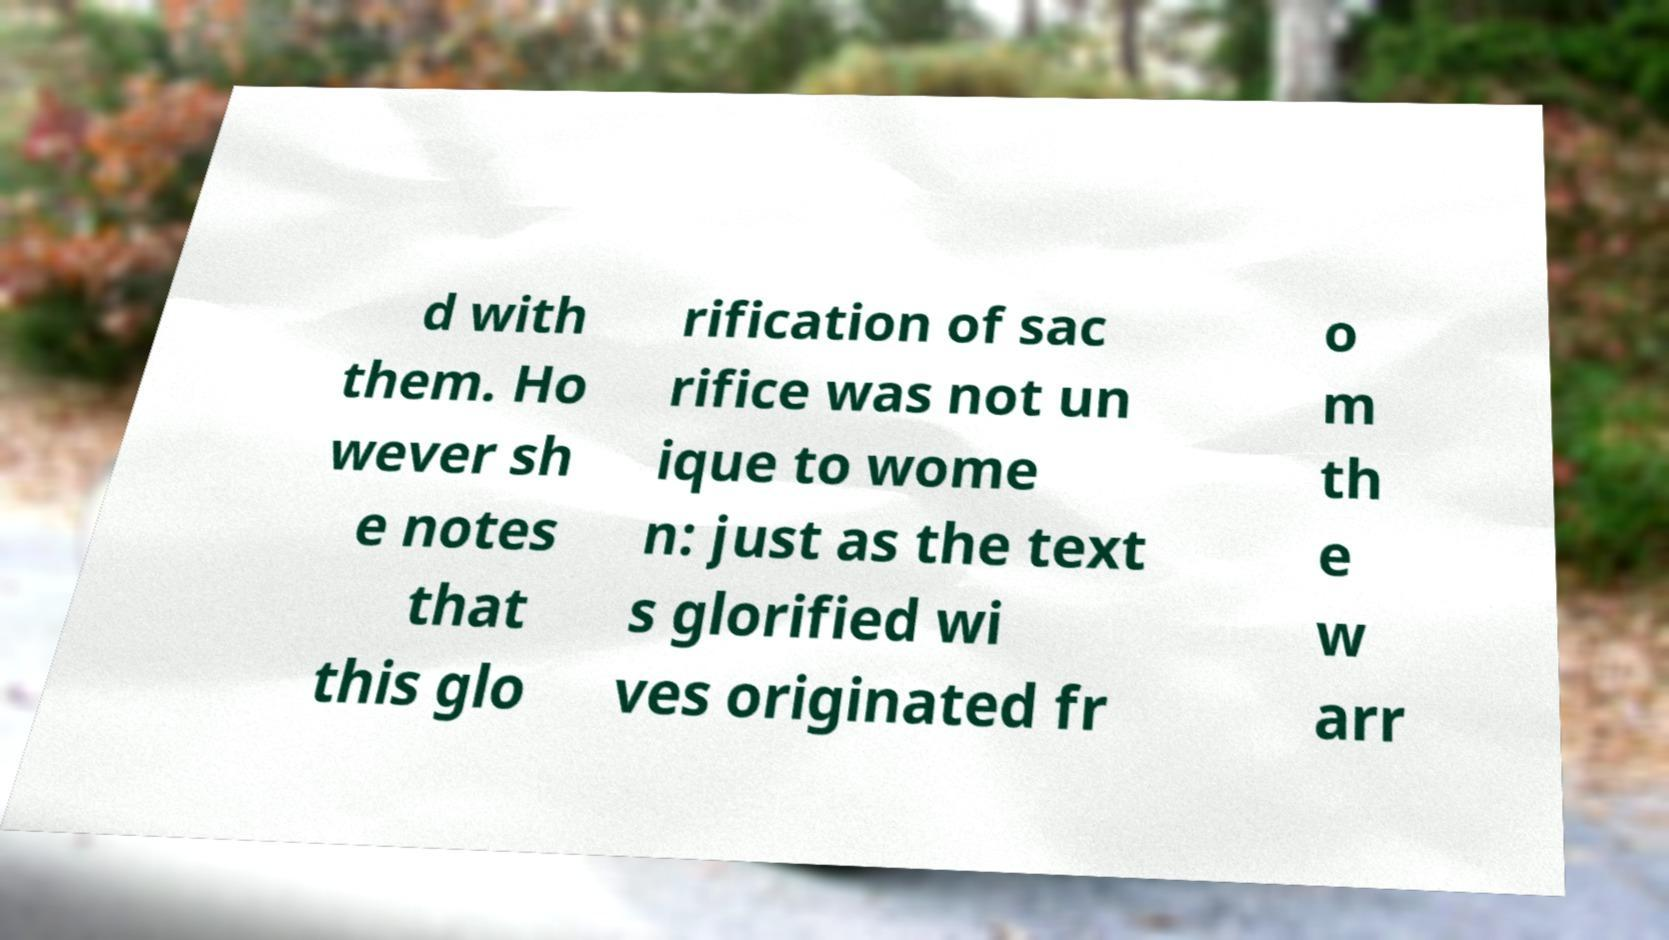Could you extract and type out the text from this image? d with them. Ho wever sh e notes that this glo rification of sac rifice was not un ique to wome n: just as the text s glorified wi ves originated fr o m th e w arr 